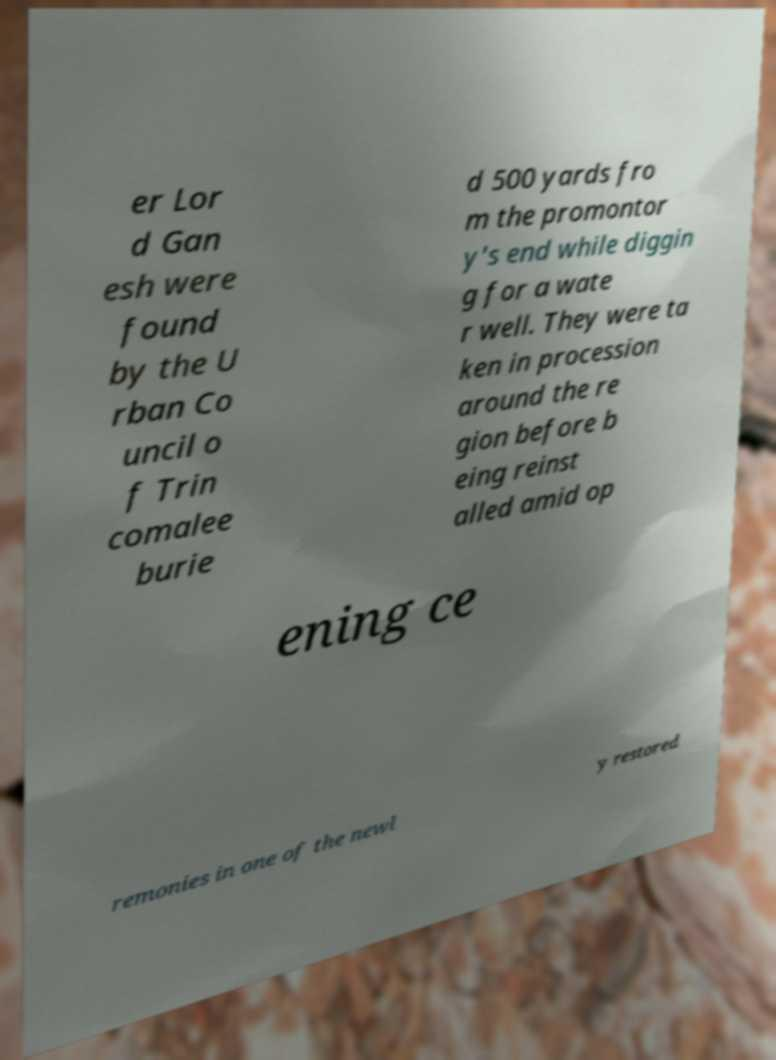For documentation purposes, I need the text within this image transcribed. Could you provide that? er Lor d Gan esh were found by the U rban Co uncil o f Trin comalee burie d 500 yards fro m the promontor y's end while diggin g for a wate r well. They were ta ken in procession around the re gion before b eing reinst alled amid op ening ce remonies in one of the newl y restored 